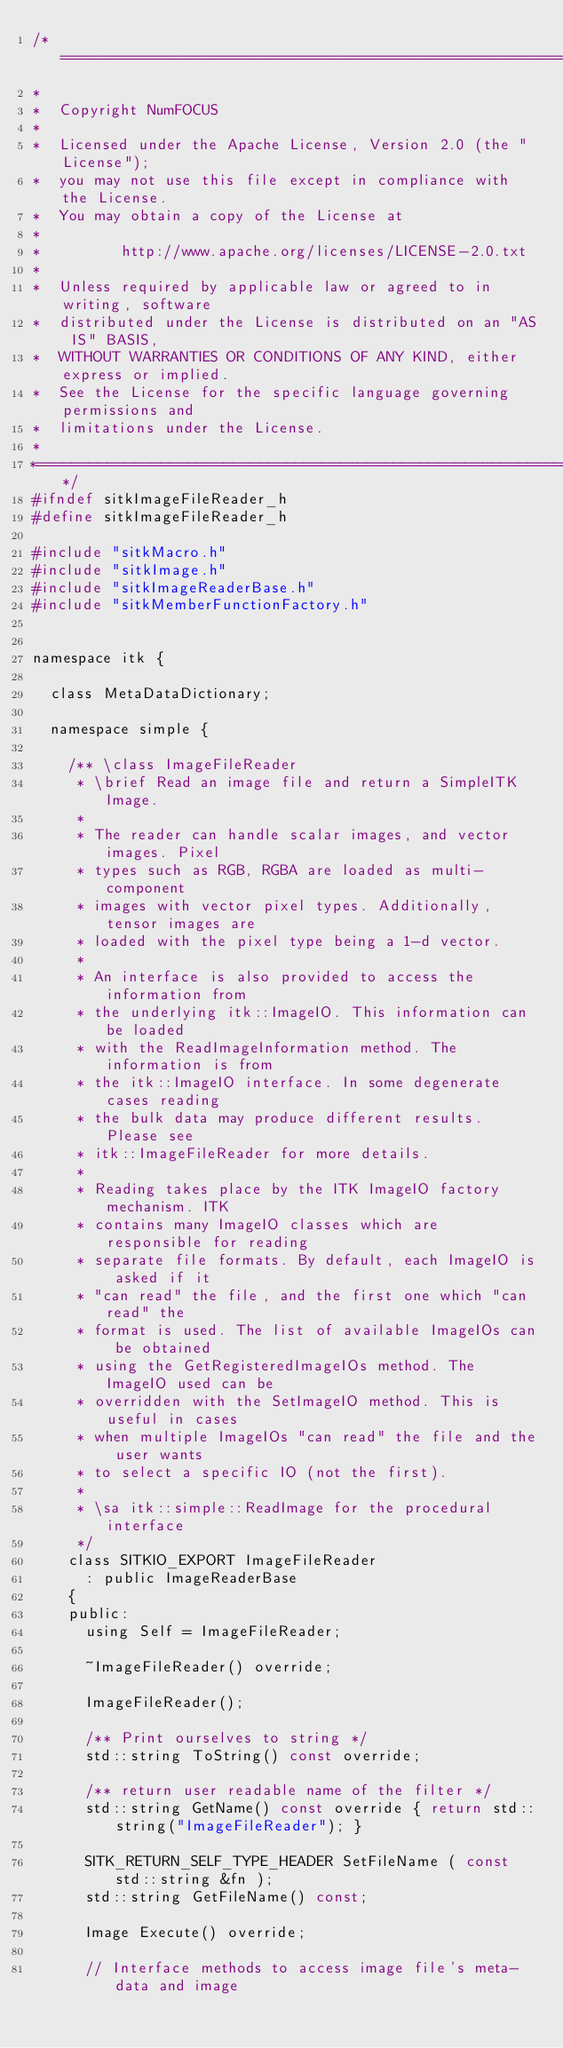Convert code to text. <code><loc_0><loc_0><loc_500><loc_500><_C_>/*=========================================================================
*
*  Copyright NumFOCUS
*
*  Licensed under the Apache License, Version 2.0 (the "License");
*  you may not use this file except in compliance with the License.
*  You may obtain a copy of the License at
*
*         http://www.apache.org/licenses/LICENSE-2.0.txt
*
*  Unless required by applicable law or agreed to in writing, software
*  distributed under the License is distributed on an "AS IS" BASIS,
*  WITHOUT WARRANTIES OR CONDITIONS OF ANY KIND, either express or implied.
*  See the License for the specific language governing permissions and
*  limitations under the License.
*
*=========================================================================*/
#ifndef sitkImageFileReader_h
#define sitkImageFileReader_h

#include "sitkMacro.h"
#include "sitkImage.h"
#include "sitkImageReaderBase.h"
#include "sitkMemberFunctionFactory.h"


namespace itk {

  class MetaDataDictionary;

  namespace simple {

    /** \class ImageFileReader
     * \brief Read an image file and return a SimpleITK Image.
     *
     * The reader can handle scalar images, and vector images. Pixel
     * types such as RGB, RGBA are loaded as multi-component
     * images with vector pixel types. Additionally, tensor images are
     * loaded with the pixel type being a 1-d vector.
     *
     * An interface is also provided to access the information from
     * the underlying itk::ImageIO. This information can be loaded
     * with the ReadImageInformation method. The information is from
     * the itk::ImageIO interface. In some degenerate cases reading
     * the bulk data may produce different results. Please see
     * itk::ImageFileReader for more details.
     *
     * Reading takes place by the ITK ImageIO factory mechanism. ITK
     * contains many ImageIO classes which are responsible for reading
     * separate file formats. By default, each ImageIO is asked if it
     * "can read" the file, and the first one which "can read" the
     * format is used. The list of available ImageIOs can be obtained
     * using the GetRegisteredImageIOs method. The ImageIO used can be
     * overridden with the SetImageIO method. This is useful in cases
     * when multiple ImageIOs "can read" the file and the user wants
     * to select a specific IO (not the first).
     *
     * \sa itk::simple::ReadImage for the procedural interface
     */
    class SITKIO_EXPORT ImageFileReader
      : public ImageReaderBase
    {
    public:
      using Self = ImageFileReader;

      ~ImageFileReader() override;

      ImageFileReader();

      /** Print ourselves to string */
      std::string ToString() const override;

      /** return user readable name of the filter */
      std::string GetName() const override { return std::string("ImageFileReader"); }

      SITK_RETURN_SELF_TYPE_HEADER SetFileName ( const std::string &fn );
      std::string GetFileName() const;

      Image Execute() override;

      // Interface methods to access image file's meta-data and image</code> 